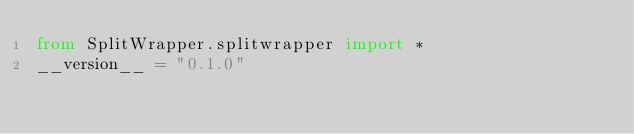Convert code to text. <code><loc_0><loc_0><loc_500><loc_500><_Python_>from SplitWrapper.splitwrapper import *
__version__ = "0.1.0"</code> 